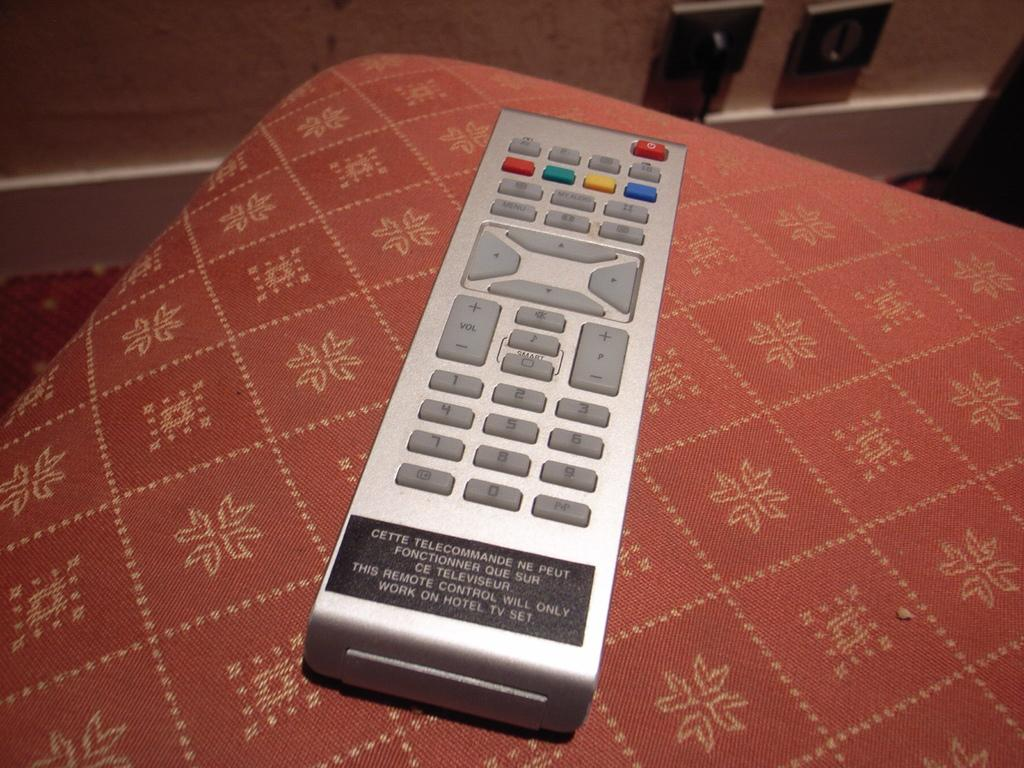Provide a one-sentence caption for the provided image. A label on a remote indicates it will only work in the hotel. 